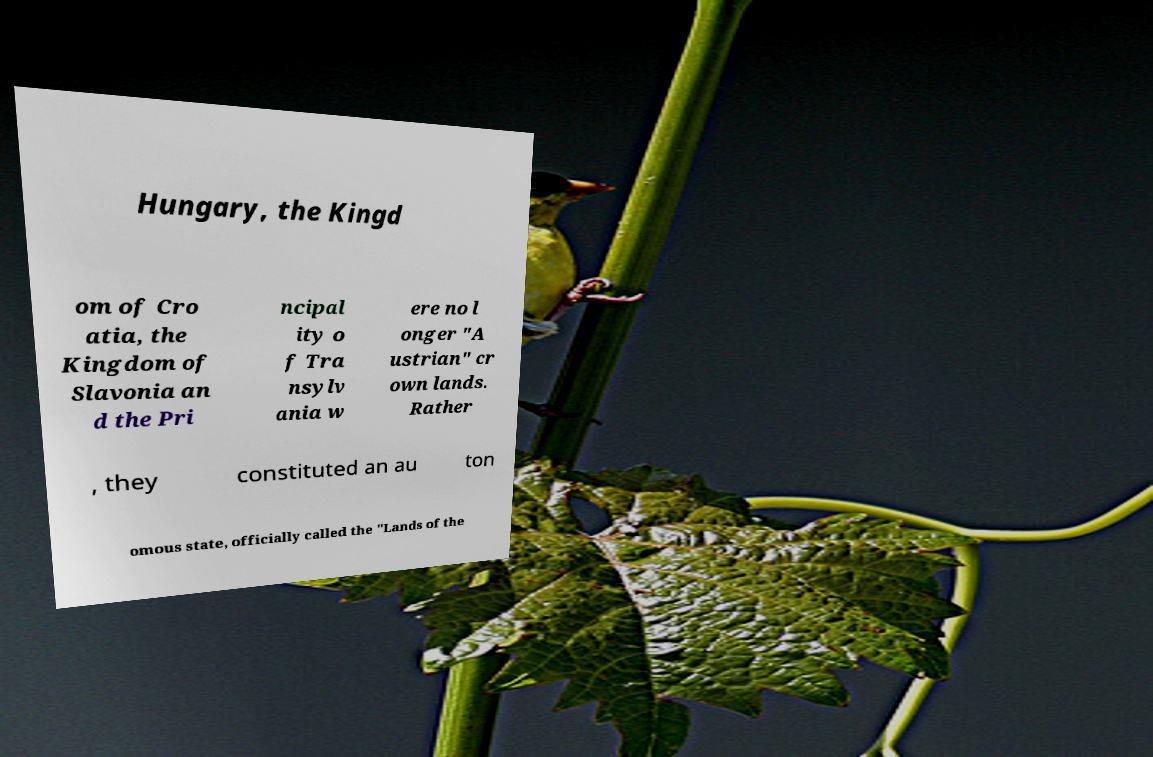Could you assist in decoding the text presented in this image and type it out clearly? Hungary, the Kingd om of Cro atia, the Kingdom of Slavonia an d the Pri ncipal ity o f Tra nsylv ania w ere no l onger "A ustrian" cr own lands. Rather , they constituted an au ton omous state, officially called the "Lands of the 